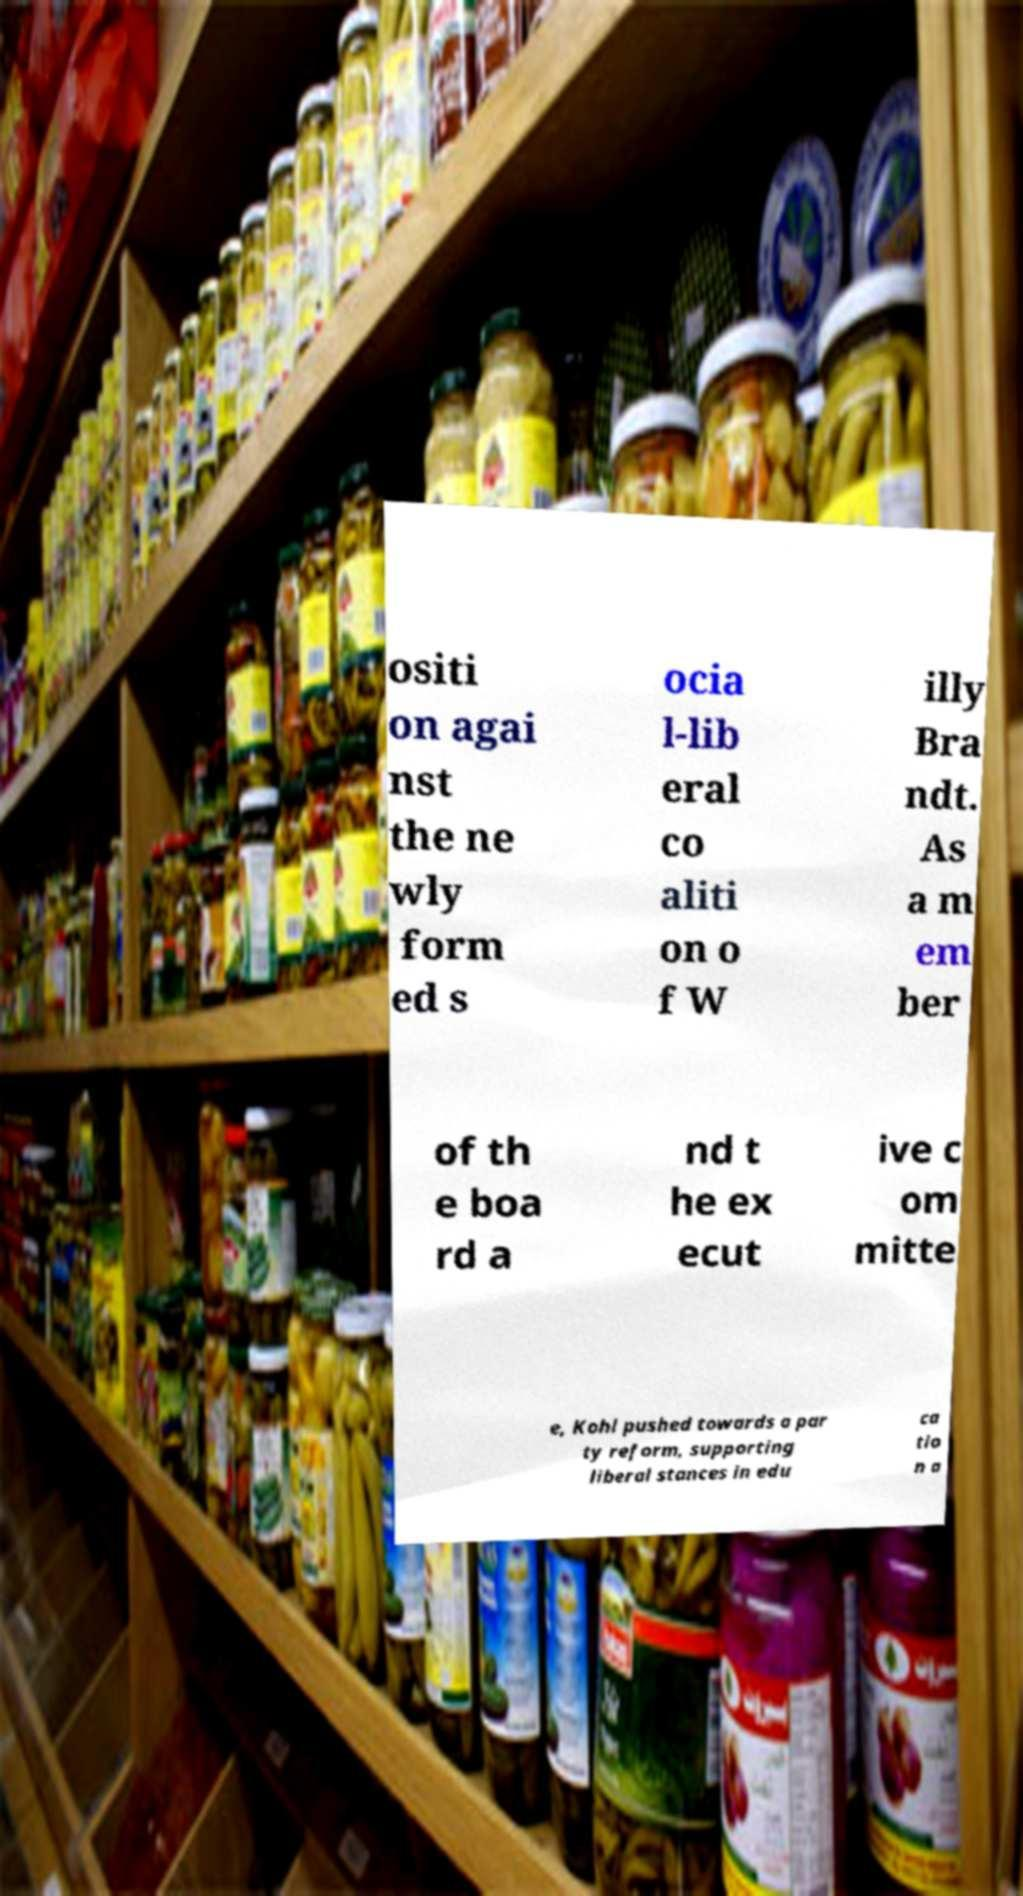Can you read and provide the text displayed in the image?This photo seems to have some interesting text. Can you extract and type it out for me? ositi on agai nst the ne wly form ed s ocia l-lib eral co aliti on o f W illy Bra ndt. As a m em ber of th e boa rd a nd t he ex ecut ive c om mitte e, Kohl pushed towards a par ty reform, supporting liberal stances in edu ca tio n a 